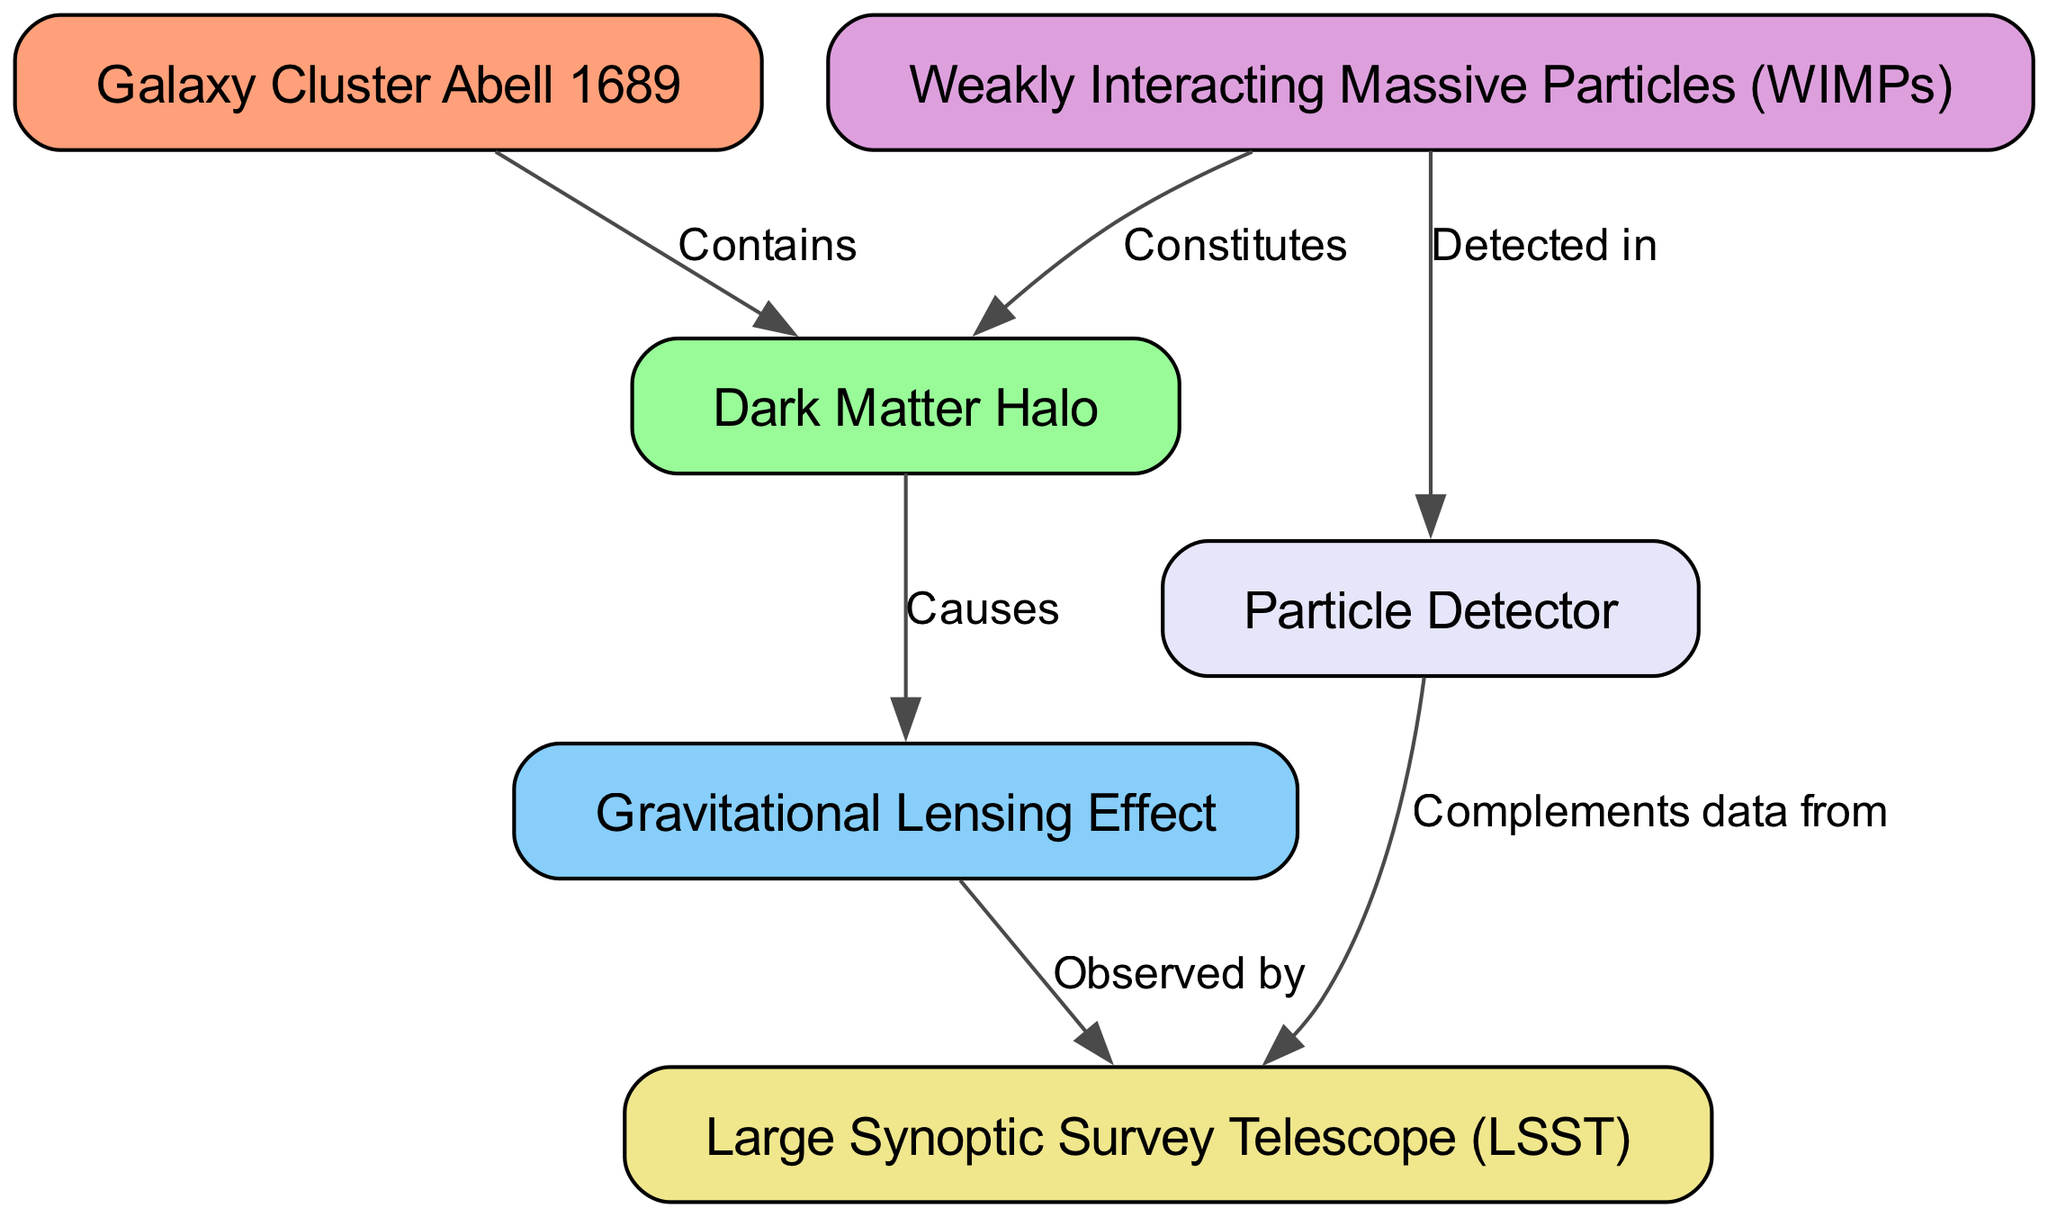What is the label of node 1? The diagram indicates that node 1 is labeled "Galaxy Cluster Abell 1689." It's shown directly in the node representative of the galaxy cluster.
Answer: Galaxy Cluster Abell 1689 How many nodes are present in the diagram? There are a total of 6 nodes in the diagram as identified in the data. Each node corresponds to a specific concept or entity related to the visualization of dark matter and gravitational lensing.
Answer: 6 Who does the dark matter halo contain? The diagram shows that the "Galaxy Cluster Abell 1689" primarily contains the "Dark Matter Halo," which is noted in the edge labeled "Contains" between these two nodes.
Answer: Dark Matter Halo What causes the gravitational lensing effect? According to the diagram, the "Dark Matter Halo" is stated to cause the "Gravitational Lensing Effect," which is indicated by the labeled edge "Causes." This describes the relationship between these two entities.
Answer: Dark Matter Halo Which particle is constituted by dark matter? The diagram indicates that "Weakly Interacting Massive Particles (WIMPs)" constitute the "Dark Matter Halo," as shown in the labeled edge "Constitutes." This explains the composition of the dark matter halo.
Answer: Weakly Interacting Massive Particles (WIMPs) How are gravitational lensing effects observed? The edge labeled "Observed by" shows that "Gravitational Lensing Effect" is observed by the "Large Synoptic Survey Telescope (LSST)," which describes the observation mechanism in this context.
Answer: Large Synoptic Survey Telescope (LSST) Which component complements the data from the Large Synoptic Survey Telescope? The diagram indicates that the "Particle Detector" complements data from the "Large Synoptic Survey Telescope (LSST)," as shown by the edge labeled "Complements data from." This explains the relationship between these two nodes regarding data enhancement.
Answer: Particle Detector What is detected in the particle detector? The diagram clearly indicates that "Weakly Interacting Massive Particles (WIMPs)" are detected in the "Particle Detector," as specified by the edge labeled "Detected in." This demonstrates what particles are being observed in this context.
Answer: Weakly Interacting Massive Particles (WIMPs) 